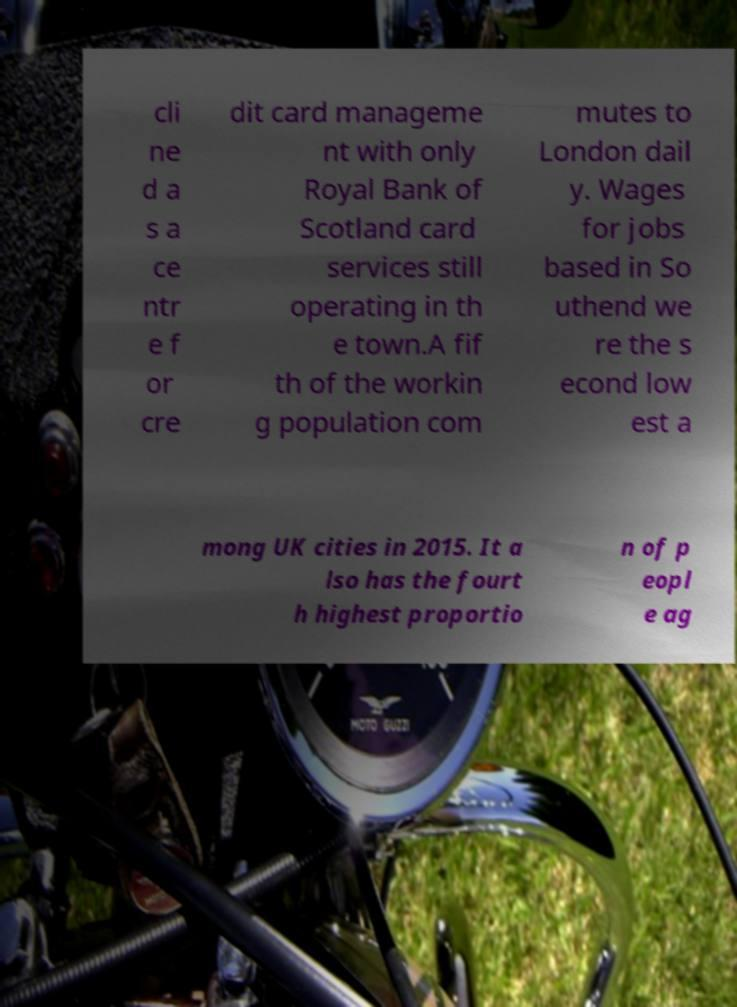I need the written content from this picture converted into text. Can you do that? cli ne d a s a ce ntr e f or cre dit card manageme nt with only Royal Bank of Scotland card services still operating in th e town.A fif th of the workin g population com mutes to London dail y. Wages for jobs based in So uthend we re the s econd low est a mong UK cities in 2015. It a lso has the fourt h highest proportio n of p eopl e ag 